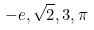<formula> <loc_0><loc_0><loc_500><loc_500>- e , \sqrt { 2 } , 3 , \pi</formula> 